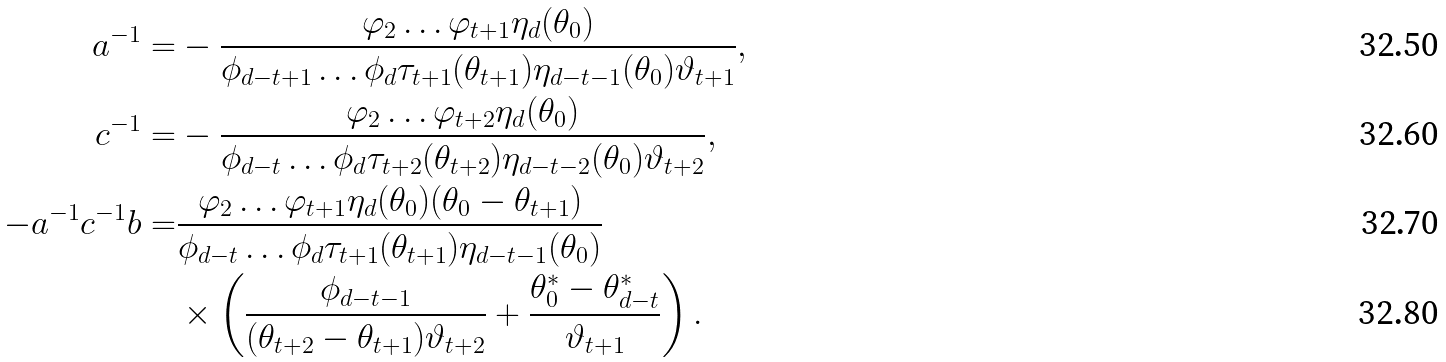Convert formula to latex. <formula><loc_0><loc_0><loc_500><loc_500>a ^ { - 1 } = & - \frac { \varphi _ { 2 } \dots \varphi _ { t + 1 } \eta _ { d } ( \theta _ { 0 } ) } { \phi _ { d - t + 1 } \dots \phi _ { d } \tau _ { t + 1 } ( \theta _ { t + 1 } ) \eta _ { d - t - 1 } ( \theta _ { 0 } ) \vartheta _ { t + 1 } } , \\ c ^ { - 1 } = & - \frac { \varphi _ { 2 } \dots \varphi _ { t + 2 } \eta _ { d } ( \theta _ { 0 } ) } { \phi _ { d - t } \dots \phi _ { d } \tau _ { t + 2 } ( \theta _ { t + 2 } ) \eta _ { d - t - 2 } ( \theta _ { 0 } ) \vartheta _ { t + 2 } } , \\ - a ^ { - 1 } c ^ { - 1 } b = & \frac { \varphi _ { 2 } \dots \varphi _ { t + 1 } \eta _ { d } ( \theta _ { 0 } ) ( \theta _ { 0 } - \theta _ { t + 1 } ) } { \phi _ { d - t } \dots \phi _ { d } \tau _ { t + 1 } ( \theta _ { t + 1 } ) \eta _ { d - t - 1 } ( \theta _ { 0 } ) } \\ & \times \left ( \frac { \phi _ { d - t - 1 } } { ( \theta _ { t + 2 } - \theta _ { t + 1 } ) \vartheta _ { t + 2 } } + \frac { \theta _ { 0 } ^ { * } - \theta _ { d - t } ^ { * } } { \vartheta _ { t + 1 } } \right ) .</formula> 